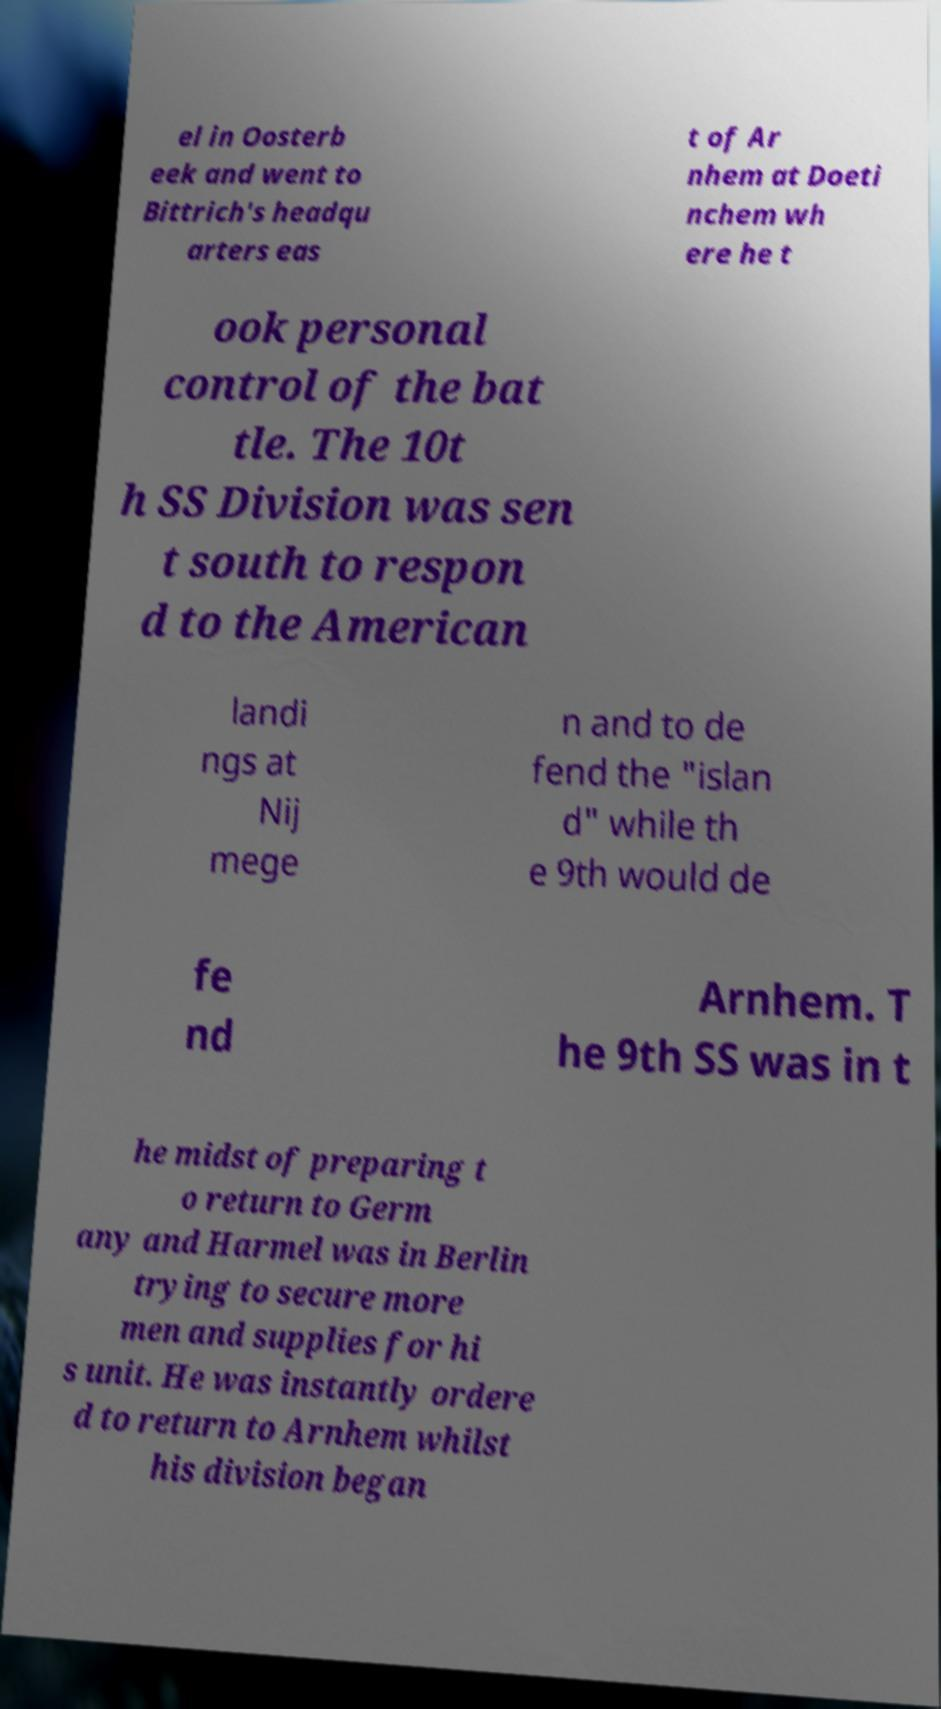What messages or text are displayed in this image? I need them in a readable, typed format. el in Oosterb eek and went to Bittrich's headqu arters eas t of Ar nhem at Doeti nchem wh ere he t ook personal control of the bat tle. The 10t h SS Division was sen t south to respon d to the American landi ngs at Nij mege n and to de fend the "islan d" while th e 9th would de fe nd Arnhem. T he 9th SS was in t he midst of preparing t o return to Germ any and Harmel was in Berlin trying to secure more men and supplies for hi s unit. He was instantly ordere d to return to Arnhem whilst his division began 